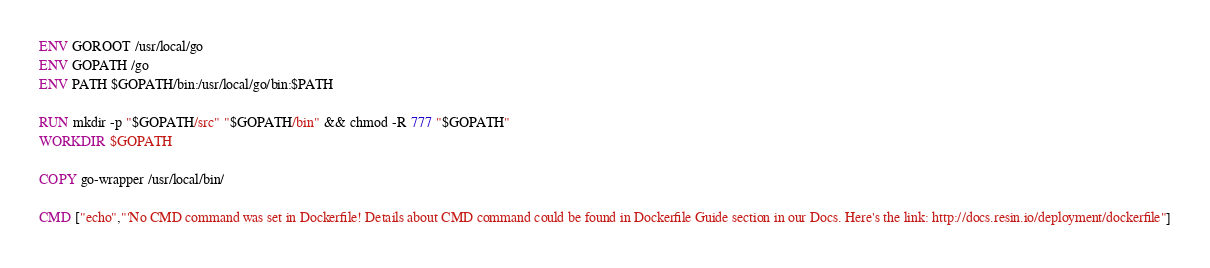Convert code to text. <code><loc_0><loc_0><loc_500><loc_500><_Dockerfile_>ENV GOROOT /usr/local/go
ENV GOPATH /go
ENV PATH $GOPATH/bin:/usr/local/go/bin:$PATH

RUN mkdir -p "$GOPATH/src" "$GOPATH/bin" && chmod -R 777 "$GOPATH"
WORKDIR $GOPATH

COPY go-wrapper /usr/local/bin/

CMD ["echo","'No CMD command was set in Dockerfile! Details about CMD command could be found in Dockerfile Guide section in our Docs. Here's the link: http://docs.resin.io/deployment/dockerfile"]
</code> 